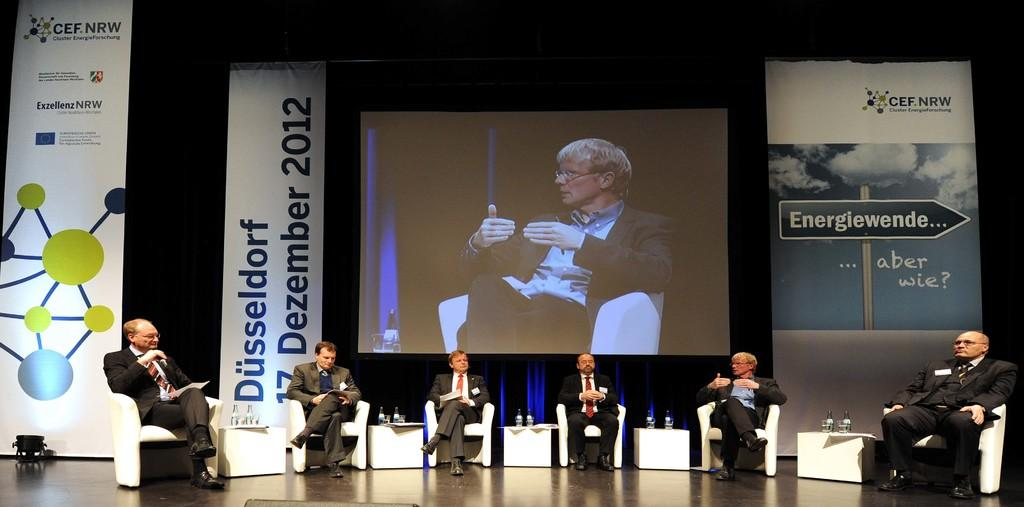What are the people in the image doing? The persons sitting on chairs at the bottom of the image are likely seated for a purpose, such as watching a presentation or attending a meeting. What can be seen in the background of the image? There is a screen, posters, and a wall in the background of the image. Can you describe the wall in the background? The wall in the background is likely a part of the room or space where the image was taken. What type of teeth can be seen on the posters in the image? There are no teeth visible on the posters in the image. Is the person's dad present in the image? There is no information provided about the person's dad, so it cannot be determined if they are present in the image. 